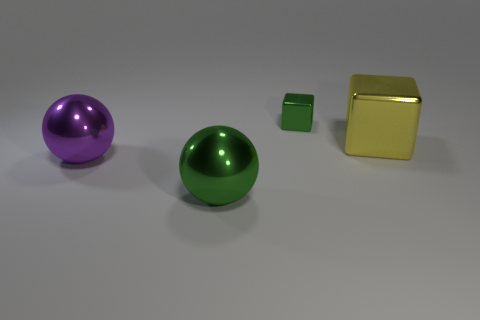There is a ball that is the same color as the small object; what size is it?
Keep it short and to the point. Large. There is a ball that is left of the large green metallic thing; is there a green block to the right of it?
Your answer should be compact. Yes. What material is the big object that is the same shape as the tiny object?
Make the answer very short. Metal. There is a big ball that is in front of the big purple sphere; what number of spheres are on the left side of it?
Ensure brevity in your answer.  1. Are there any other things of the same color as the small cube?
Offer a terse response. Yes. How many things are either big green metal balls or large objects on the left side of the tiny green thing?
Your response must be concise. 2. What material is the thing that is behind the large shiny thing that is on the right side of the green metallic object in front of the tiny green cube?
Give a very brief answer. Metal. The yellow block that is the same material as the purple ball is what size?
Give a very brief answer. Large. What color is the shiny cube on the right side of the green thing behind the large yellow shiny cube?
Your response must be concise. Yellow. What number of large green balls have the same material as the large yellow block?
Offer a very short reply. 1. 